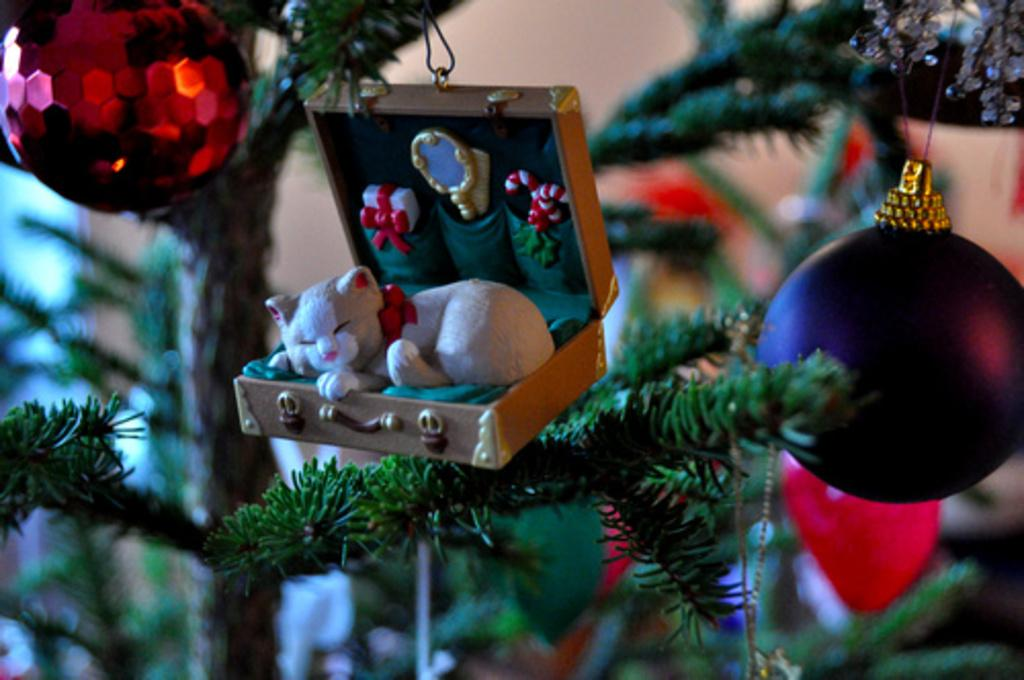What is the main subject of the image? The main subject of the image is a Christmas tree. What type of decorations are on the Christmas tree? There are balls on the Christmas tree. Is there anything unusual hanging on the tree? Yes, there is a box hanging on the tree. What is inside the box on the tree? A cat is lying inside the box on the tree. What day of the week is it in the image? The day of the week is not mentioned or depicted in the image. Can you tell me what the grandmother is doing in the image? There is no grandmother present in the image. 